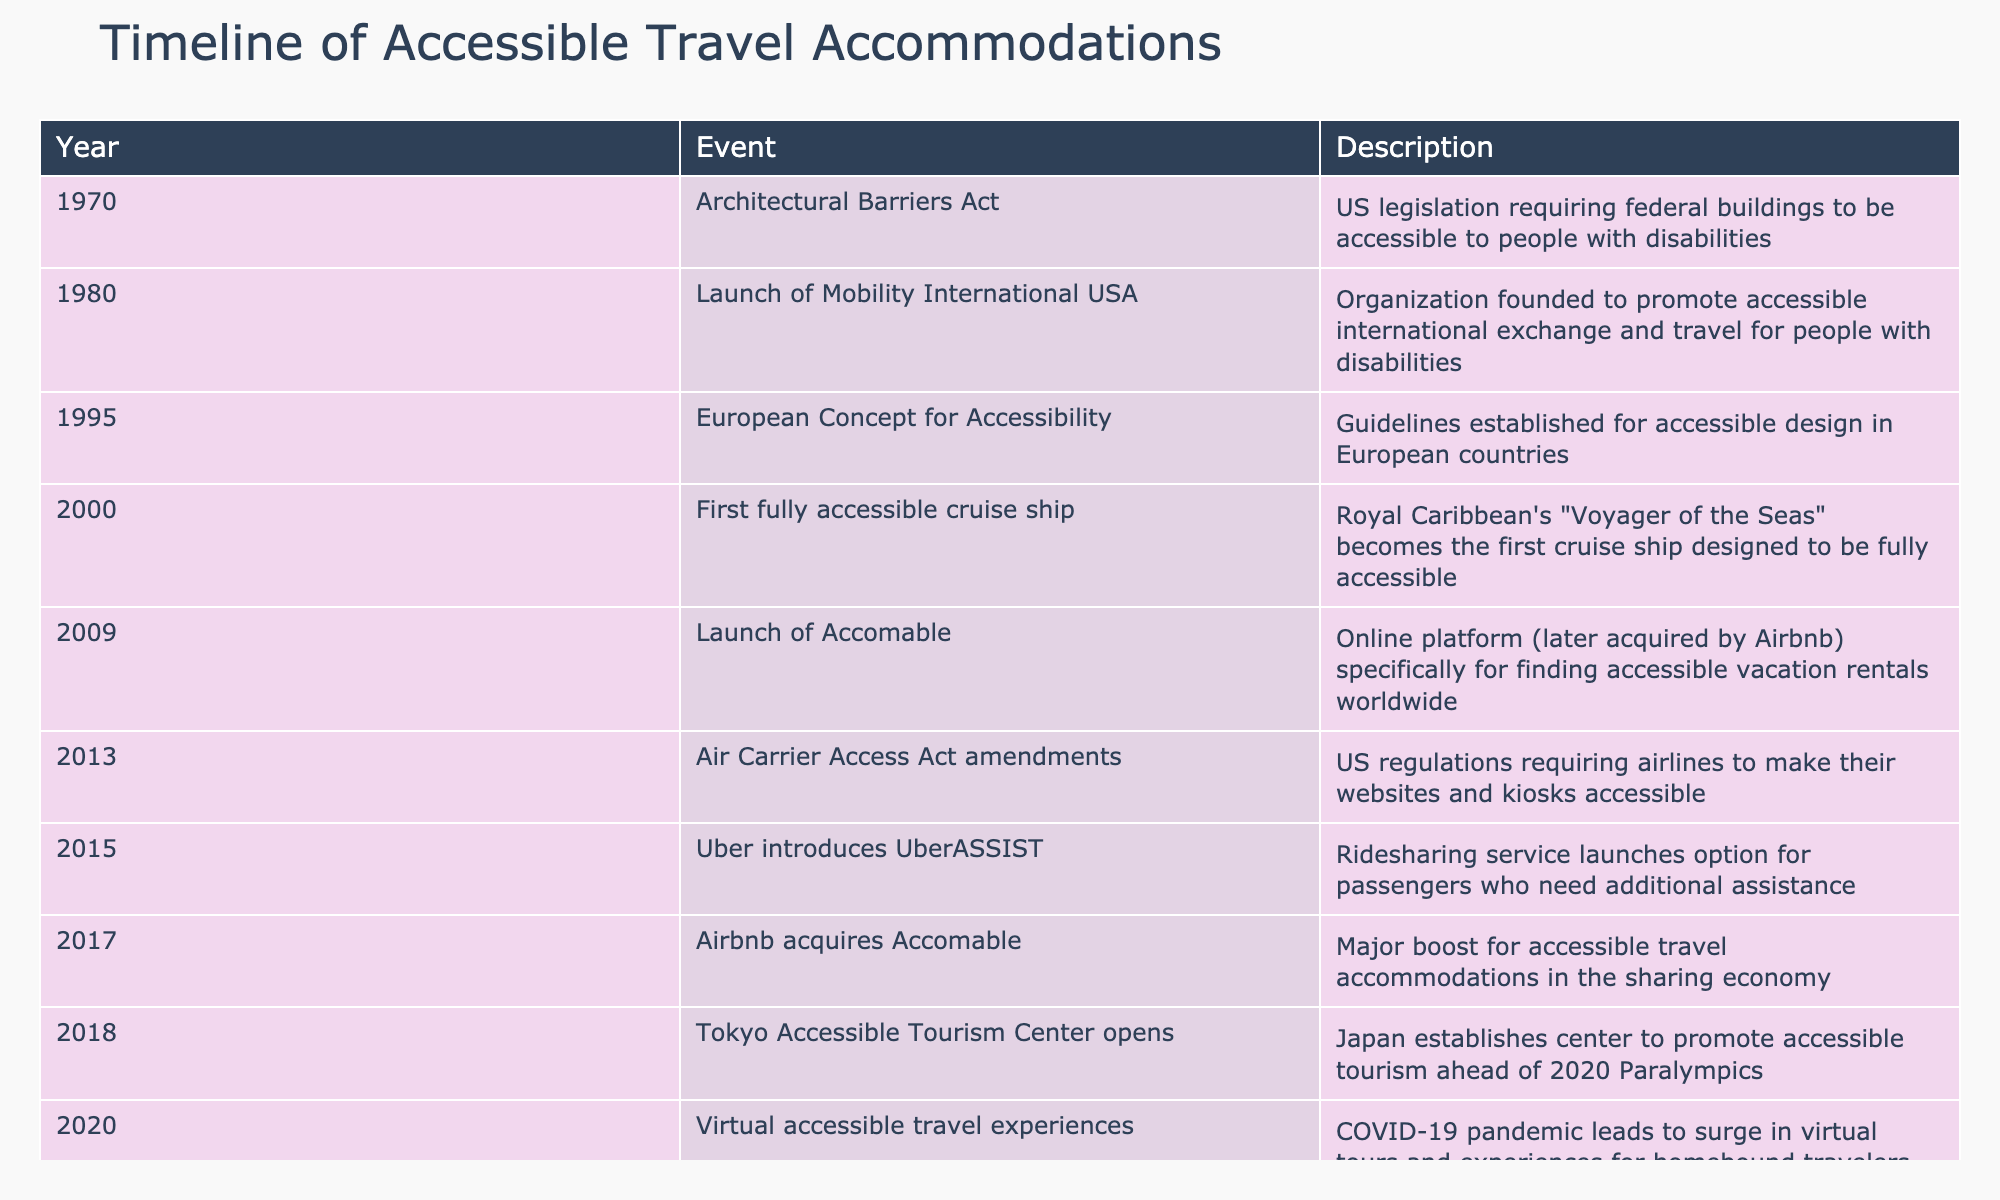What year was the Architectural Barriers Act enacted? The table lists the year 1970 under the event "Architectural Barriers Act," indicating that this act was enacted in that year.
Answer: 1970 Which company launched the first fully accessible cruise ship? The table shows that "Royal Caribbean" launched the first fully accessible cruise ship named "Voyager of the Seas" in the year 2000.
Answer: Royal Caribbean How many events occurred prior to 2010? By checking the years listed before 2010 (1970, 1980, 1995, 2000, 2009), we find there are 5 events that occurred before that year.
Answer: 5 Was the Accomable platform launched before the amendments to the Air Carrier Access Act? The table indicates that Accomable was launched in 2009 and the amendments to the Air Carrier Access Act occurred in 2013. Since 2009 is before 2013, the answer is yes.
Answer: Yes Which event marked a significant development in accessible travel accommodations during the sharing economy? From the table, we can see that Airbnb acquired Accomable in 2017, which represents a significant boost in accessible travel accommodations within the sharing economy.
Answer: Airbnb acquires Accomable What is the time gap between the launch of Mobility International USA and the first fully accessible cruise ship? The launch of Mobility International USA was in 1980 and the first fully accessible cruise ship debuted in 2000. The difference in years is 2000 - 1980 = 20 years.
Answer: 20 years Did the Tokyo Accessible Tourism Center open after the COVID-19 pandemic began? The table states that the Tokyo Accessible Tourism Center opened in 2018, while the COVID-19 pandemic began in early 2020. Since 2018 is before 2020, the answer is no.
Answer: No What impact did the COVID-19 pandemic have on travel experiences, according to the timeline? In 2020, the timeline indicates that virtual accessible travel experiences surged due to the COVID-19 pandemic, signifying a shift in how travel experiences were delivered during that time.
Answer: Surge in virtual experiences What is the total number of events listed in the timeline? By counting the number of rows in the table, there are 10 unique events listed in the timeline of accessible travel accommodations.
Answer: 10 